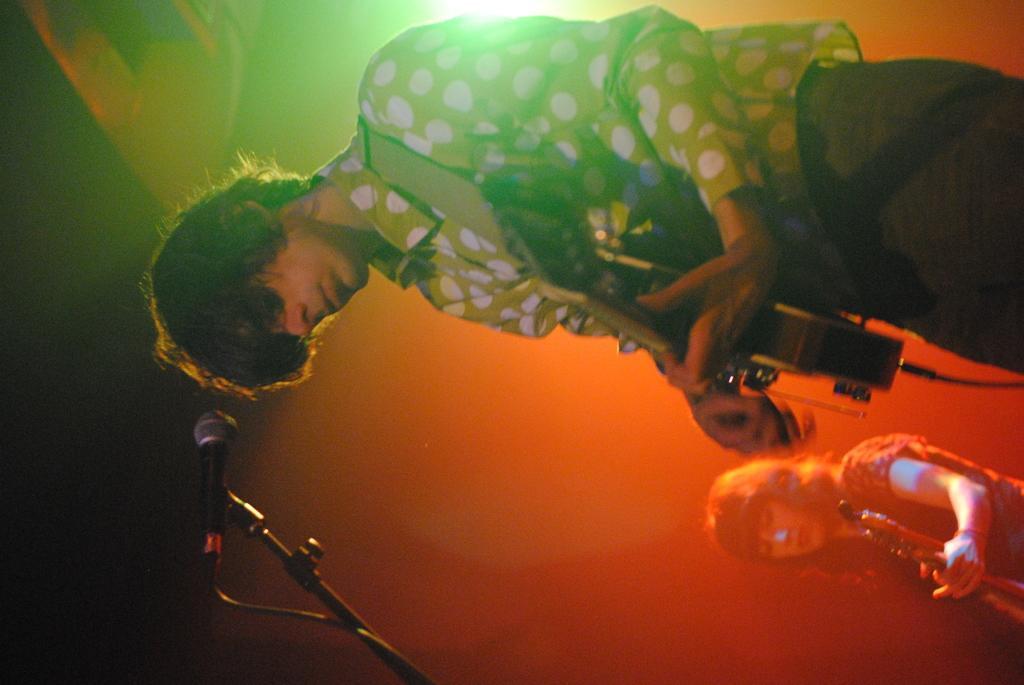Describe this image in one or two sentences. In this image we can see two people are playing musical instruments. In-front of that person there is a mic and mic stand. 